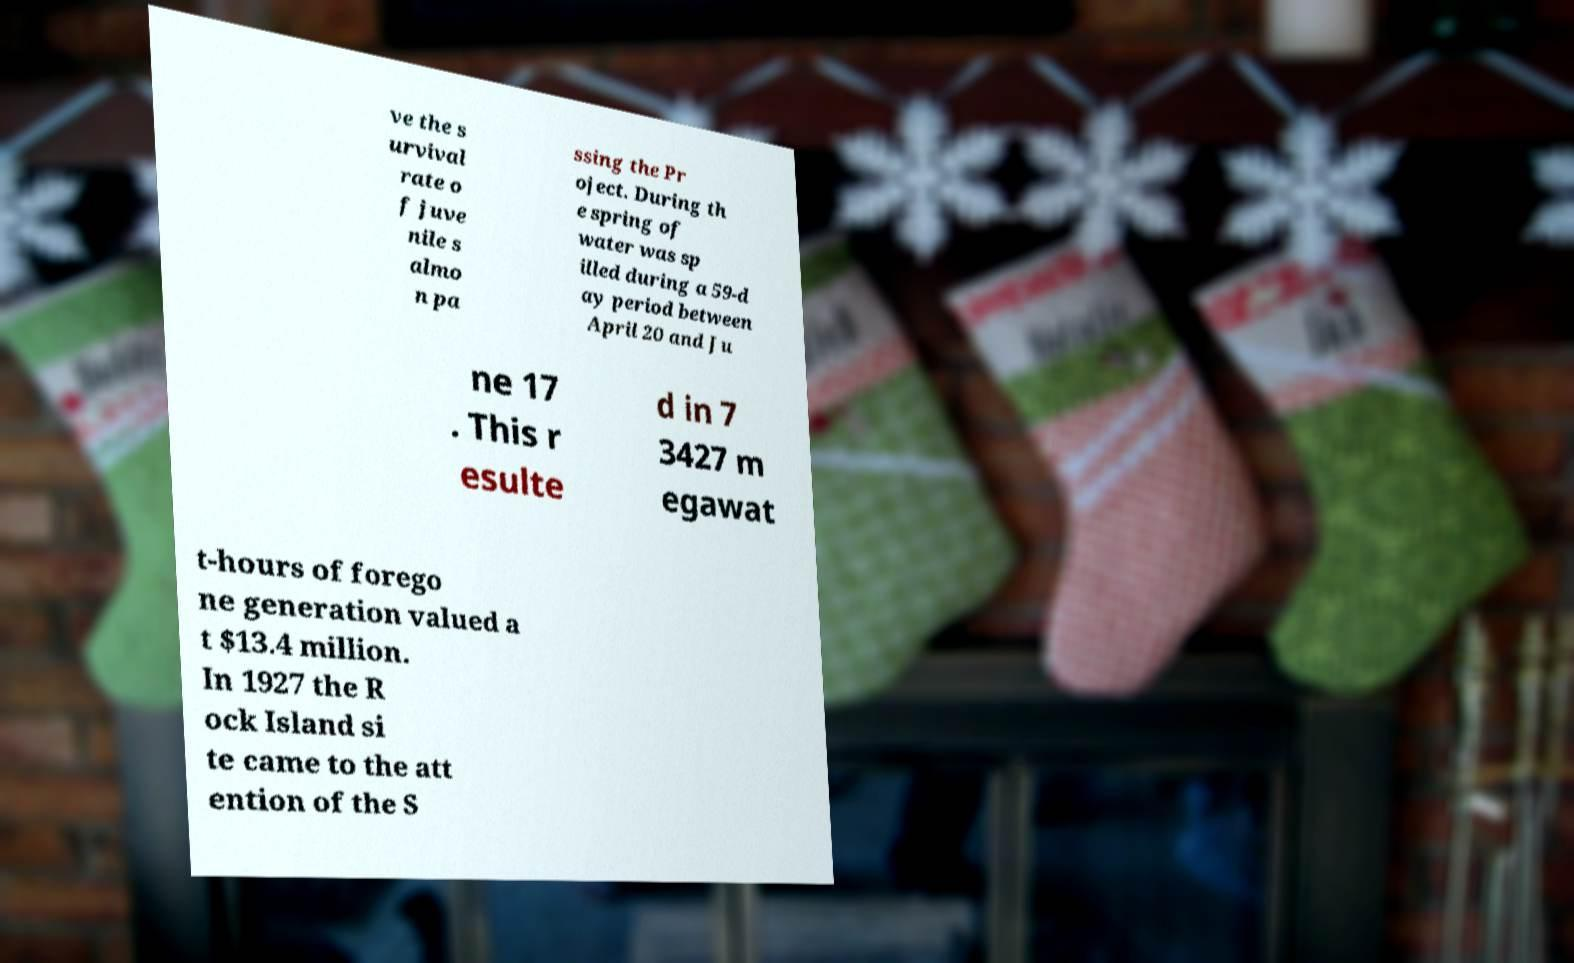Can you accurately transcribe the text from the provided image for me? ve the s urvival rate o f juve nile s almo n pa ssing the Pr oject. During th e spring of water was sp illed during a 59-d ay period between April 20 and Ju ne 17 . This r esulte d in 7 3427 m egawat t-hours of forego ne generation valued a t $13.4 million. In 1927 the R ock Island si te came to the att ention of the S 